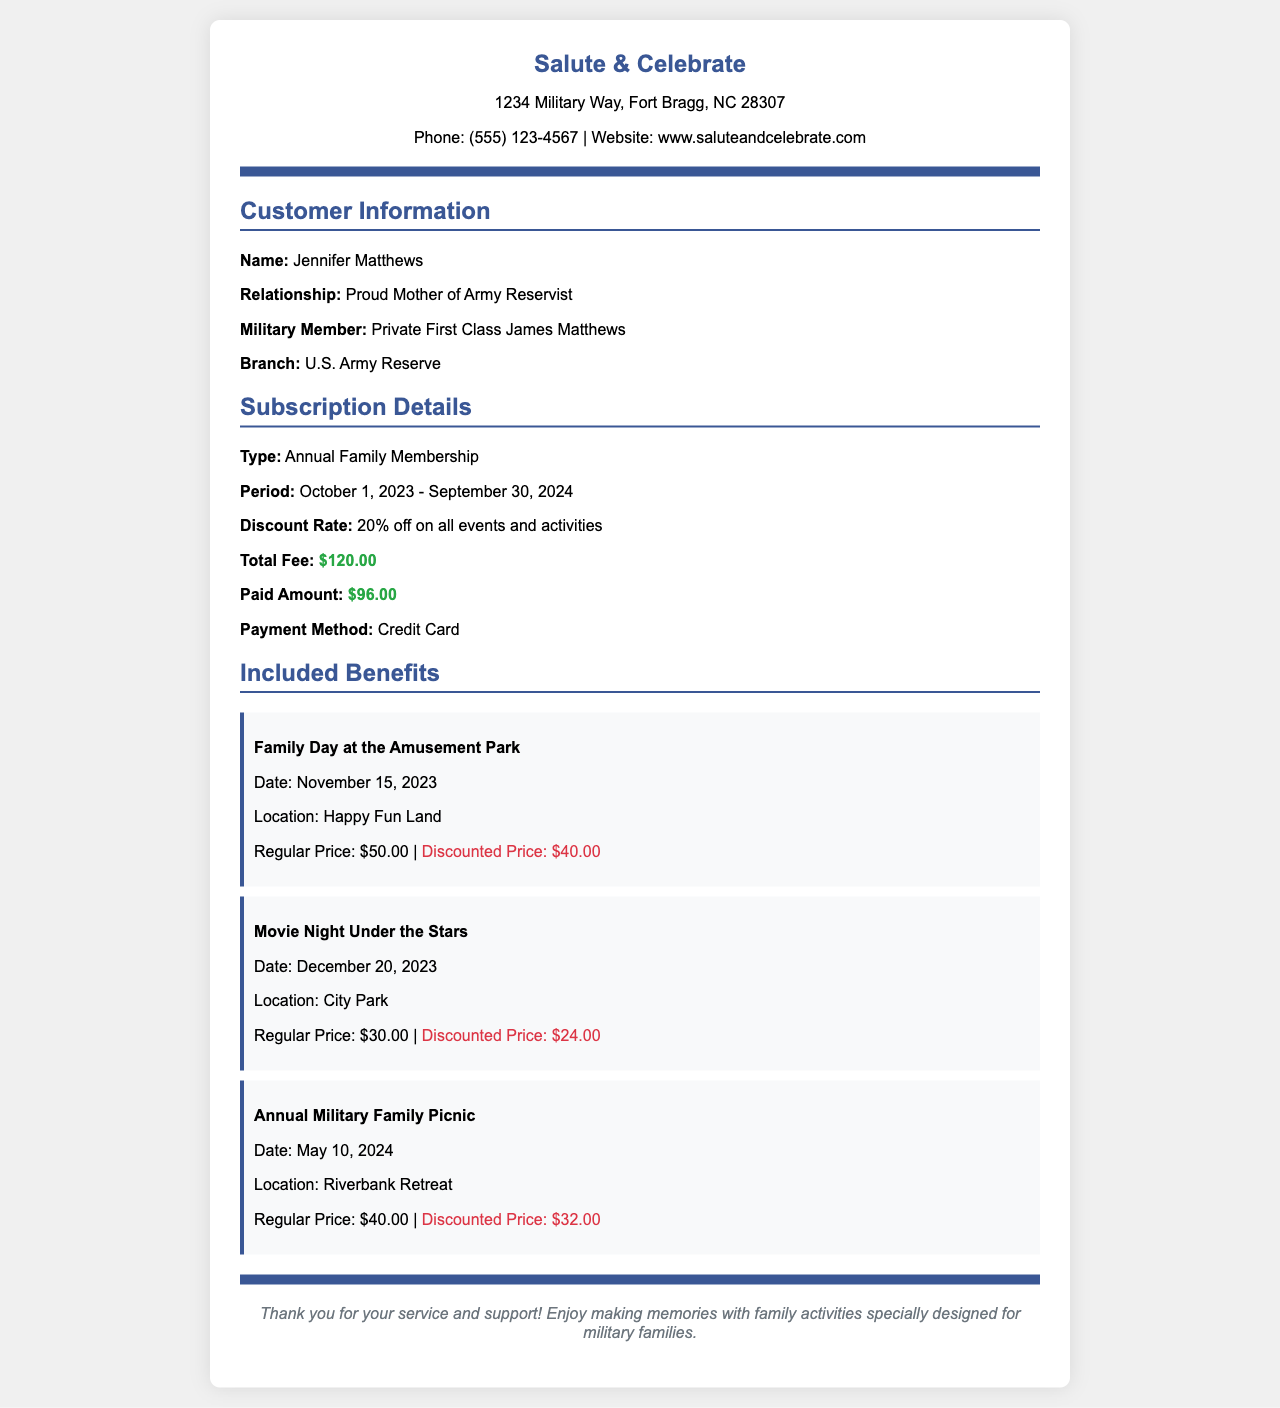What is the total fee for the subscription? The total fee for the subscription is listed in the subscription details section, which is $120.00.
Answer: $120.00 What is the discount rate provided? The discount rate for the subscription is outlined in the subscription details, and it states 20% off on all events and activities.
Answer: 20% off Who is the military member associated with this receipt? The military member's name is provided in the customer information section, specifically Private First Class James Matthews.
Answer: Private First Class James Matthews What is the payment method used? The payment method is clearly mentioned in the subscription details, which is Credit Card.
Answer: Credit Card What is the location for the Annual Military Family Picnic? The location for this event is given in the event details, which is Riverbank Retreat.
Answer: Riverbank Retreat What is the discounted price for the Family Day at the Amusement Park? The discounted price can be found in the event details for Family Day at the Amusement Park, which is $40.00.
Answer: $40.00 What is the relationship of the customer to the military member? The relationship is specified in the customer information section as Proud Mother of Army Reservist.
Answer: Proud Mother of Army Reservist What dates does the subscription cover? The subscription period is mentioned in the subscription details, which is from October 1, 2023, to September 30, 2024.
Answer: October 1, 2023 - September 30, 2024 